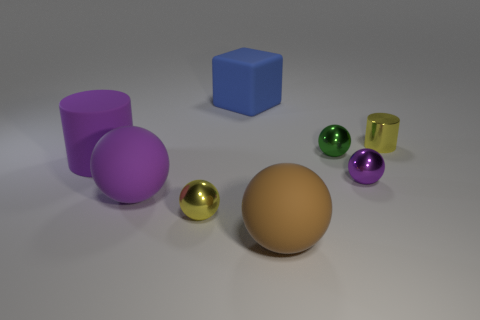Subtract 2 spheres. How many spheres are left? 3 Subtract all tiny green shiny balls. How many balls are left? 4 Subtract all red spheres. Subtract all purple cubes. How many spheres are left? 5 Add 1 small brown cylinders. How many objects exist? 9 Subtract all cubes. How many objects are left? 7 Subtract all green matte cylinders. Subtract all tiny yellow balls. How many objects are left? 7 Add 1 big blue things. How many big blue things are left? 2 Add 5 large cylinders. How many large cylinders exist? 6 Subtract 1 yellow cylinders. How many objects are left? 7 